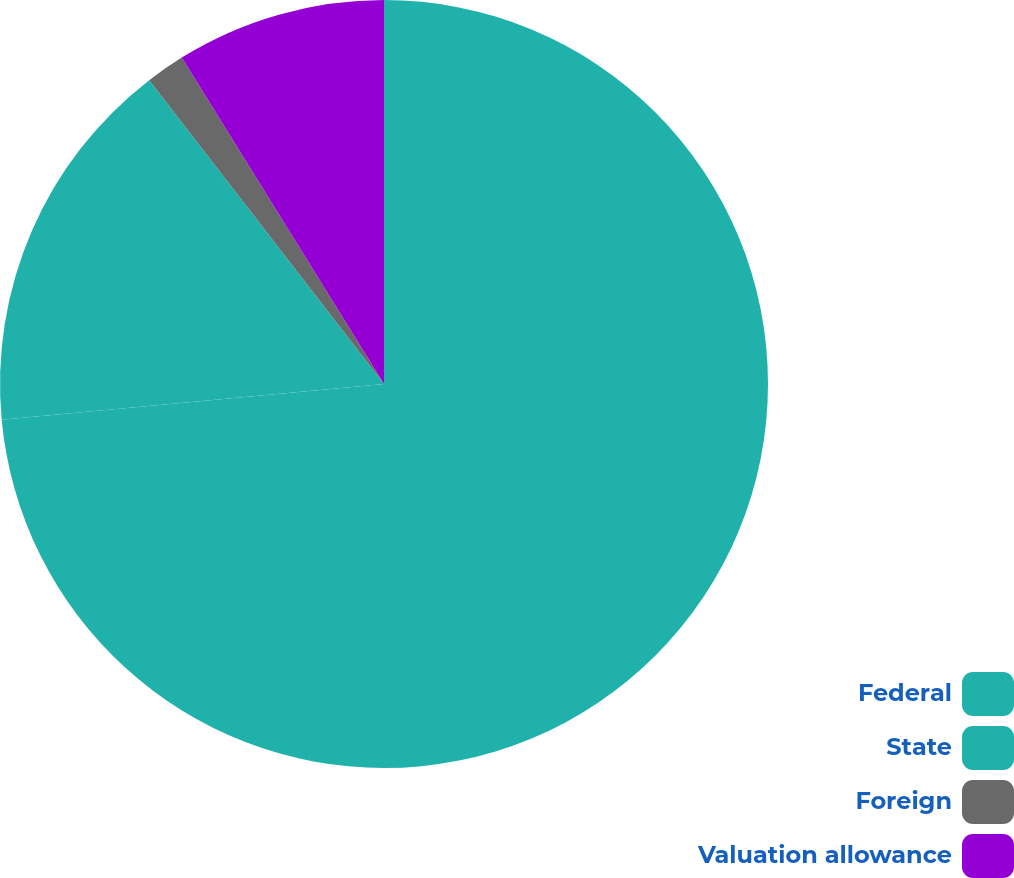Convert chart to OTSL. <chart><loc_0><loc_0><loc_500><loc_500><pie_chart><fcel>Federal<fcel>State<fcel>Foreign<fcel>Valuation allowance<nl><fcel>73.52%<fcel>16.01%<fcel>1.64%<fcel>8.83%<nl></chart> 